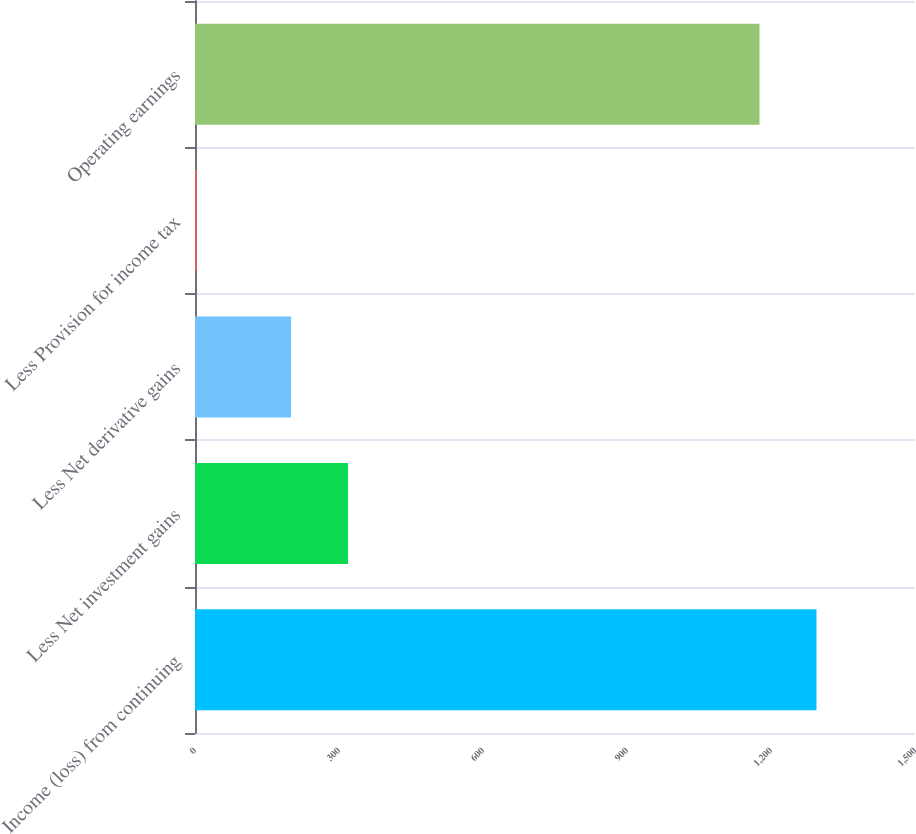<chart> <loc_0><loc_0><loc_500><loc_500><bar_chart><fcel>Income (loss) from continuing<fcel>Less Net investment gains<fcel>Less Net derivative gains<fcel>Less Provision for income tax<fcel>Operating earnings<nl><fcel>1294.7<fcel>318.7<fcel>200<fcel>3<fcel>1176<nl></chart> 